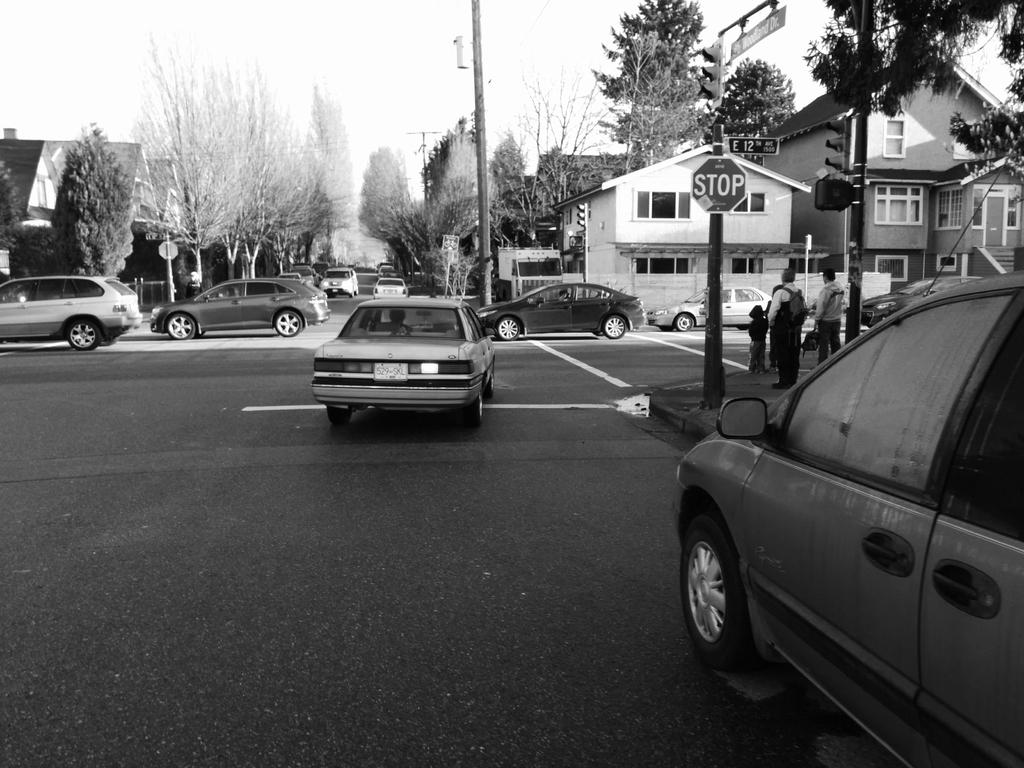What is the color scheme of the image? The image is black and white. What type of vehicles can be seen in the image? There are cars in the image. What are the people in the image doing? The people are standing in the image. Where are the people standing? The people are standing on a footpath. What other objects can be seen in the image? There are poles, trees, and houses in the image. How many cows are grazing on the plate in the image? There are no cows or plates present in the image. What type of plough is being used by the people in the image? There is no plough present in the image; it features cars, people, and other objects mentioned in the conversation. 